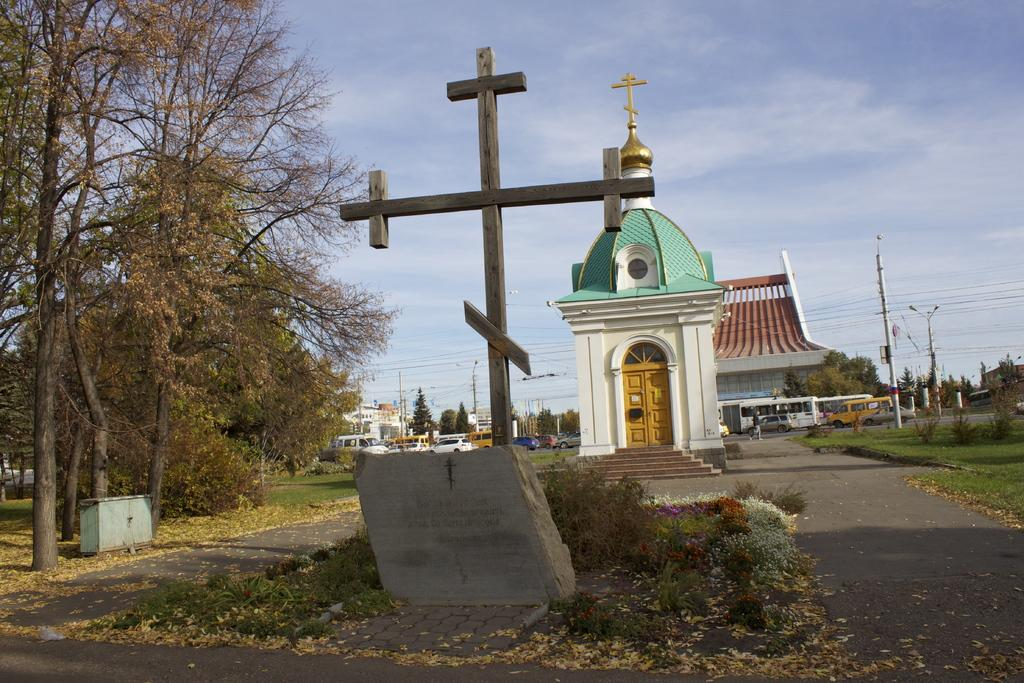What is located in the foreground of the image? There is a plus pole and a stone in the foreground of the image. What structures can be seen in the background of the image? There are houses, a church, and poles in the background of the image. What type of vegetation is visible in the background of the image? There are trees in the background of the image. What else can be seen in the background of the image? There are vehicles and the sky visible in the background of the image. Can you tell me how many grapes are hanging from the plus pole in the image? There are no grapes present in the image; the foreground features a plus pole and a stone. How does the toe of the person in the image affect the church's architecture? There is no person or toe visible in the image; it only shows a plus pole, a stone, and various structures and elements in the background. 